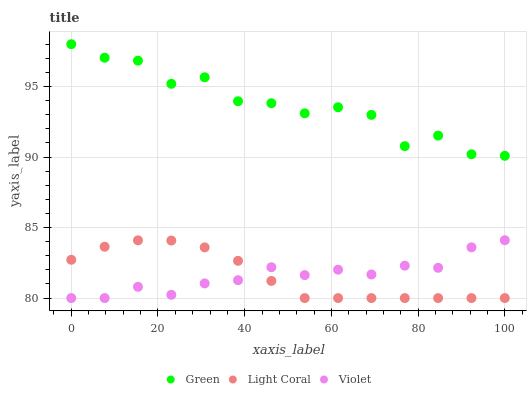Does Light Coral have the minimum area under the curve?
Answer yes or no. Yes. Does Green have the maximum area under the curve?
Answer yes or no. Yes. Does Violet have the minimum area under the curve?
Answer yes or no. No. Does Violet have the maximum area under the curve?
Answer yes or no. No. Is Light Coral the smoothest?
Answer yes or no. Yes. Is Green the roughest?
Answer yes or no. Yes. Is Violet the smoothest?
Answer yes or no. No. Is Violet the roughest?
Answer yes or no. No. Does Light Coral have the lowest value?
Answer yes or no. Yes. Does Green have the lowest value?
Answer yes or no. No. Does Green have the highest value?
Answer yes or no. Yes. Does Violet have the highest value?
Answer yes or no. No. Is Violet less than Green?
Answer yes or no. Yes. Is Green greater than Violet?
Answer yes or no. Yes. Does Violet intersect Light Coral?
Answer yes or no. Yes. Is Violet less than Light Coral?
Answer yes or no. No. Is Violet greater than Light Coral?
Answer yes or no. No. Does Violet intersect Green?
Answer yes or no. No. 